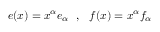Convert formula to latex. <formula><loc_0><loc_0><loc_500><loc_500>e ( x ) = x ^ { \alpha } e _ { \alpha } \ \ , \ \ f ( x ) = x ^ { \alpha } f _ { \alpha }</formula> 